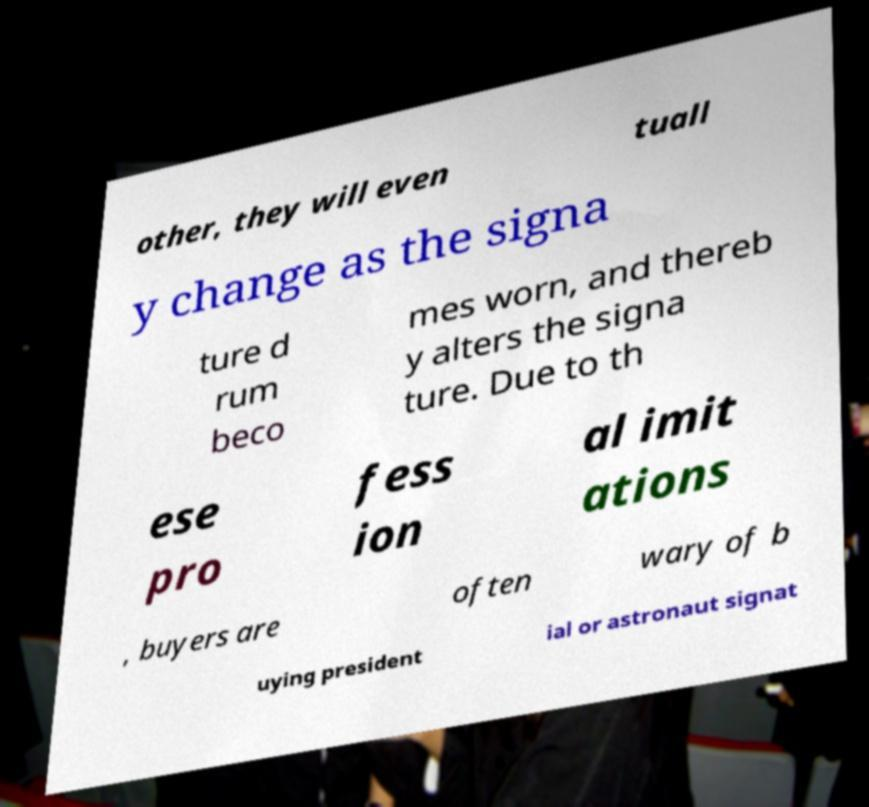Please read and relay the text visible in this image. What does it say? other, they will even tuall y change as the signa ture d rum beco mes worn, and thereb y alters the signa ture. Due to th ese pro fess ion al imit ations , buyers are often wary of b uying president ial or astronaut signat 